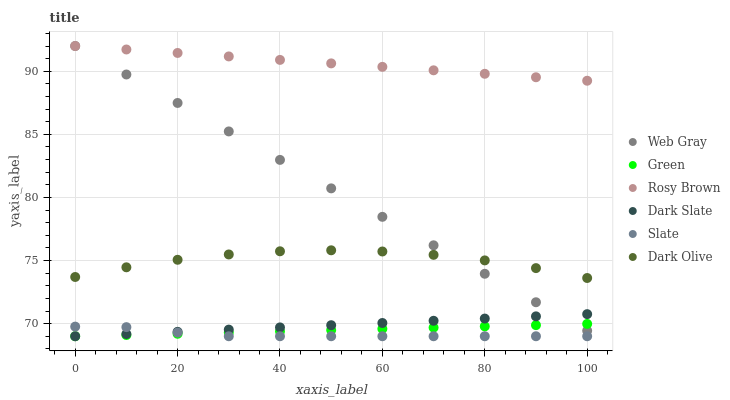Does Slate have the minimum area under the curve?
Answer yes or no. Yes. Does Rosy Brown have the maximum area under the curve?
Answer yes or no. Yes. Does Dark Olive have the minimum area under the curve?
Answer yes or no. No. Does Dark Olive have the maximum area under the curve?
Answer yes or no. No. Is Rosy Brown the smoothest?
Answer yes or no. Yes. Is Dark Olive the roughest?
Answer yes or no. Yes. Is Slate the smoothest?
Answer yes or no. No. Is Slate the roughest?
Answer yes or no. No. Does Slate have the lowest value?
Answer yes or no. Yes. Does Dark Olive have the lowest value?
Answer yes or no. No. Does Web Gray have the highest value?
Answer yes or no. Yes. Does Dark Olive have the highest value?
Answer yes or no. No. Is Dark Olive less than Rosy Brown?
Answer yes or no. Yes. Is Rosy Brown greater than Green?
Answer yes or no. Yes. Does Dark Slate intersect Web Gray?
Answer yes or no. Yes. Is Dark Slate less than Web Gray?
Answer yes or no. No. Is Dark Slate greater than Web Gray?
Answer yes or no. No. Does Dark Olive intersect Rosy Brown?
Answer yes or no. No. 